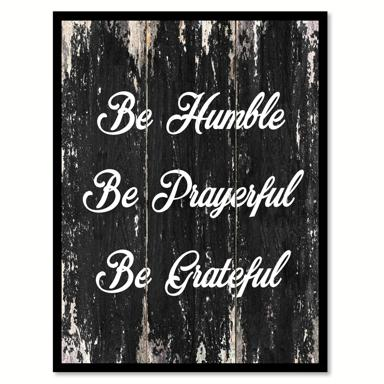What are the three phrases mentioned in the image? The image displays three inspiring phrases set against a distressed wooden background. The phrases are 'Be Humble,' 'Be Prayerful,' and 'Be Grateful.' Each phrase encourages virtues and mindfulness, and the rustic aesthetic of the background emphasizes a humble, grounded attitude. 